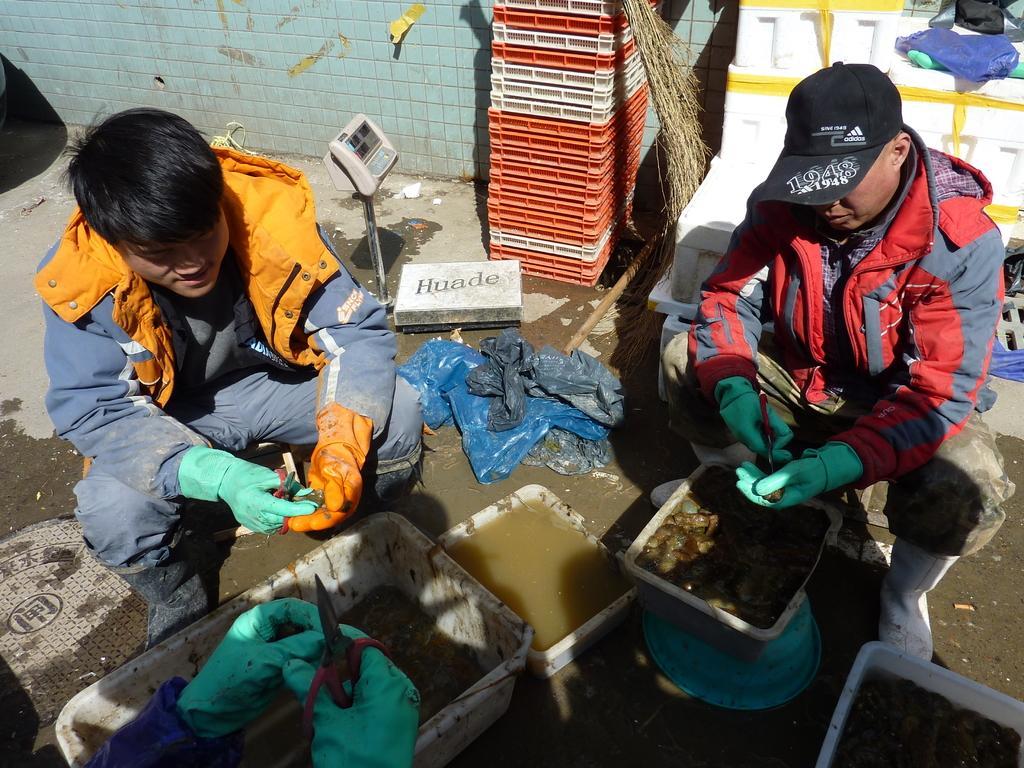In one or two sentences, can you explain what this image depicts? In this picture I can see three persons holding scissors, there are two persons sitting, there are some objects in the plastic trays, there is a weighing machine, and in the background there are some objects. 